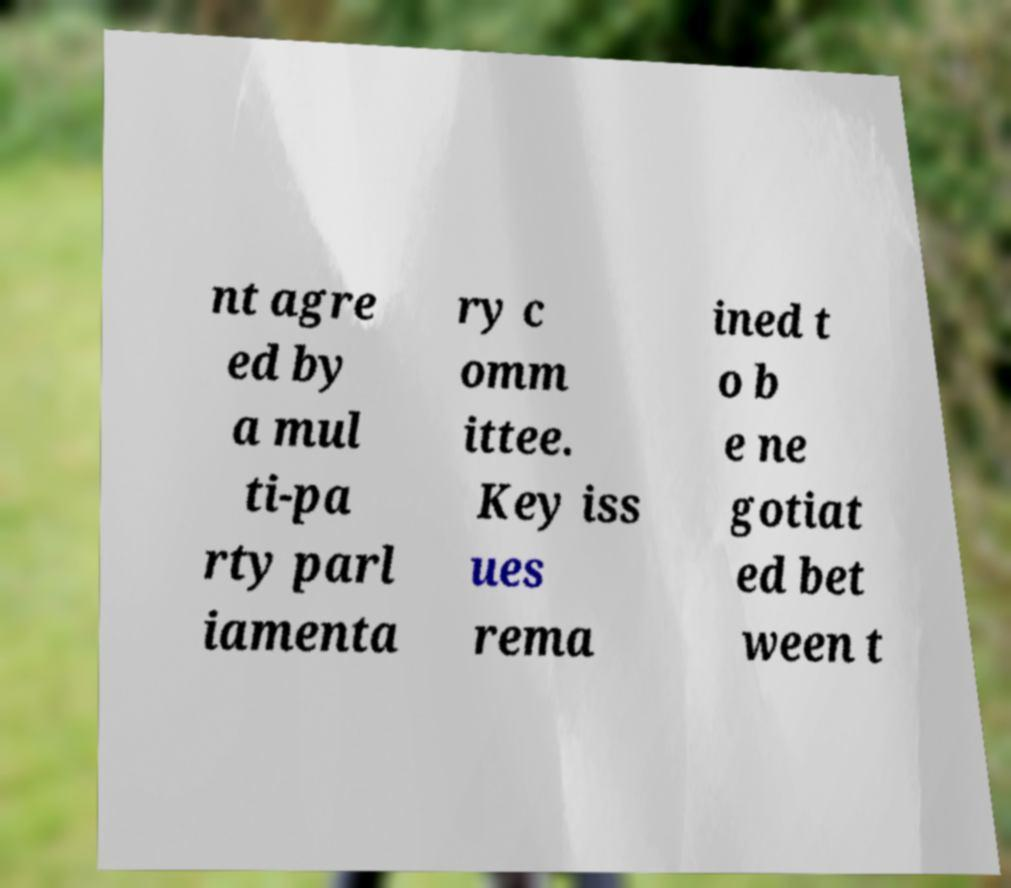Could you assist in decoding the text presented in this image and type it out clearly? nt agre ed by a mul ti-pa rty parl iamenta ry c omm ittee. Key iss ues rema ined t o b e ne gotiat ed bet ween t 